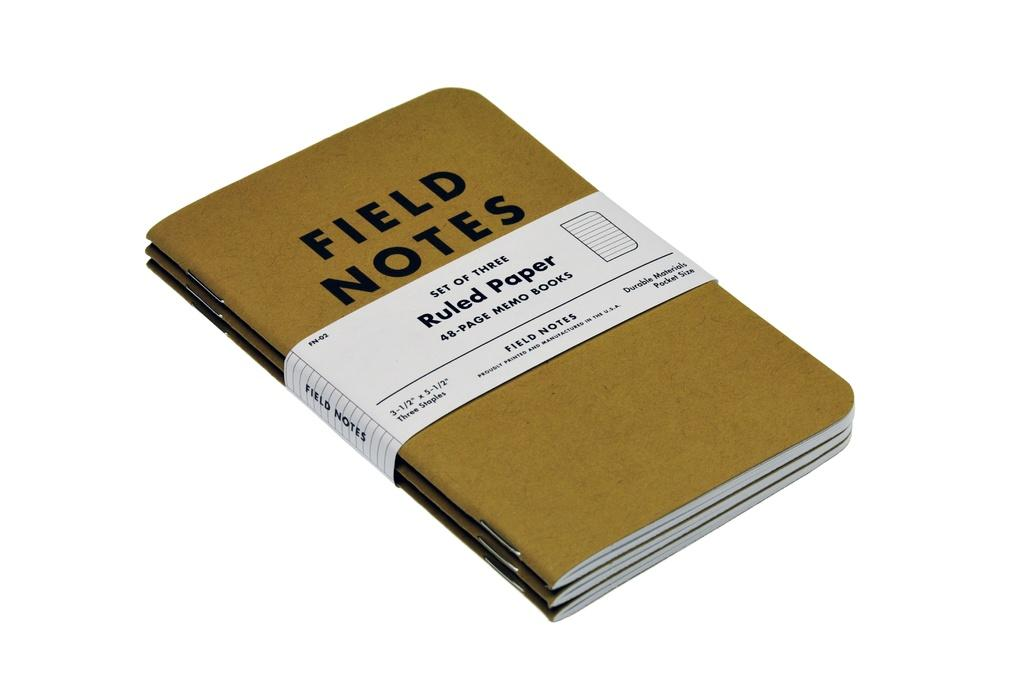Provide a one-sentence caption for the provided image. Three brown books called Field Notes are held together by a white piece of cardboard. 